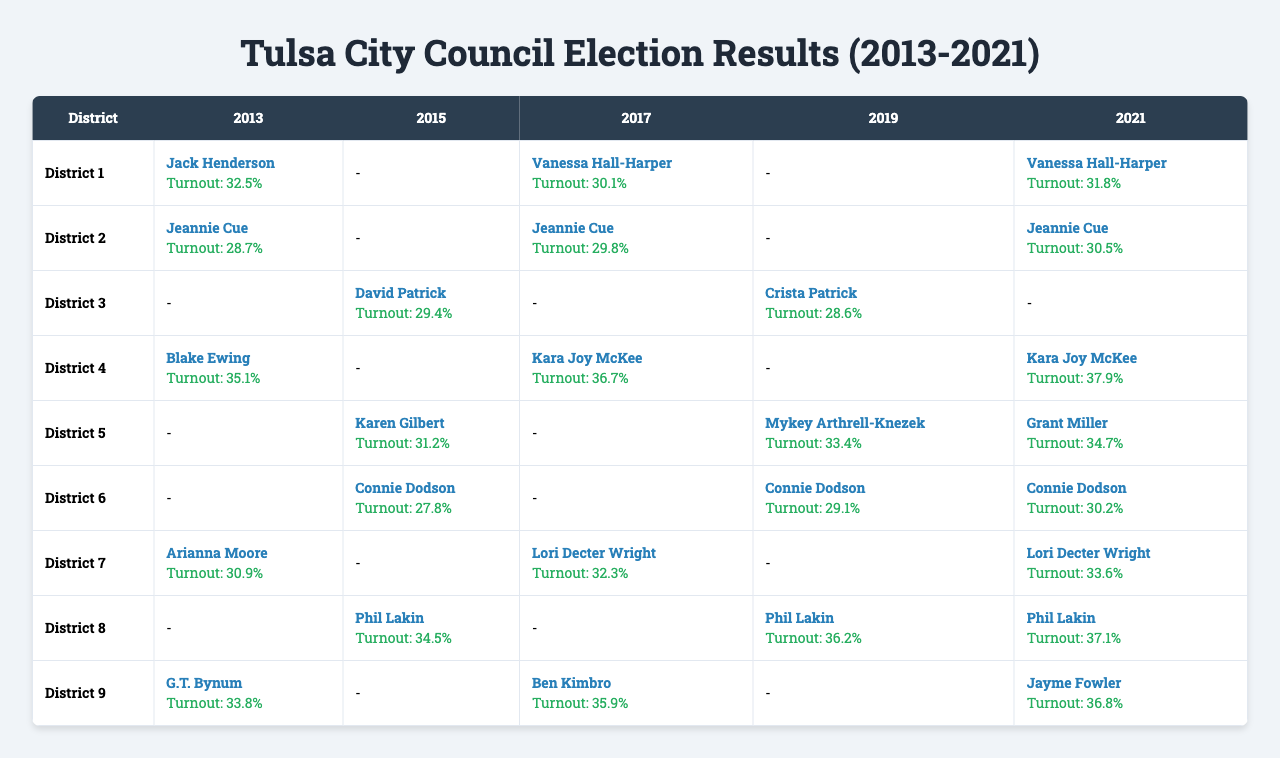What was the voter turnout in District 4 for the year 2021? The table shows that in 2021, the turnout for District 4 is listed as 37.9%.
Answer: 37.9% Who won the election in District 5 in 2019? The table indicates that in 2019, Mykey Arthrell-Knezek won the election in District 5.
Answer: Mykey Arthrell-Knezek Which district had the highest voter turnout in 2017? Looking at the voter turnout figures for 2017, District 4 has the highest turnout at 36.7%.
Answer: District 4 What is the average voter turnout across all districts for the year 2015? The relevant turnouts for 2015 are: District 3 (29.4%), District 5 (31.2%), District 6 (27.8%), District 8 (34.5%). The average is (29.4 + 31.2 + 27.8 + 34.5)/4 = 30.57%.
Answer: 30.57% Did any district have a turnout of 30% or more in the 2013 elections? Looking at the 2013 data, District 1 (32.5%), District 4 (35.1%), District 7 (30.9%), and District 9 (33.8%) all had turnouts of 30% or more. Thus, the answer is yes.
Answer: Yes Which candidate had the lowest voter turnout in any district across all years? Analyzing the turnout data, Connie Dodson had the lowest turnout at 27.8% in District 6 in 2015.
Answer: Connie Dodson How many times did Jeannie Cue win her district in the past decade? Jeannie Cue won in District 2 in 2013, 2015, and 2017. She is identified as the winner in her district for those years, making it 3 wins.
Answer: 3 What was the change in voter turnout for District 1 from 2013 to 2021? The turnout for District 1 in 2013 was 32.5% and in 2021 it was 31.8%. The change is a decrease of 0.7%.
Answer: Decrease of 0.7% Which district consistently had a winning candidate in the last three elections? District 8 shows Phil Lakin winning in both 2015 and 2019, and he won again in 2021, making it consistent over the last three elections.
Answer: District 8 Was there a district that had a winner who was not the same in consecutive elections? Yes, in District 1, Vanessa Hall-Harper won in 2017 and 2021, but Jack Henderson won in 2013. Thus, there was a change between elections.
Answer: Yes 